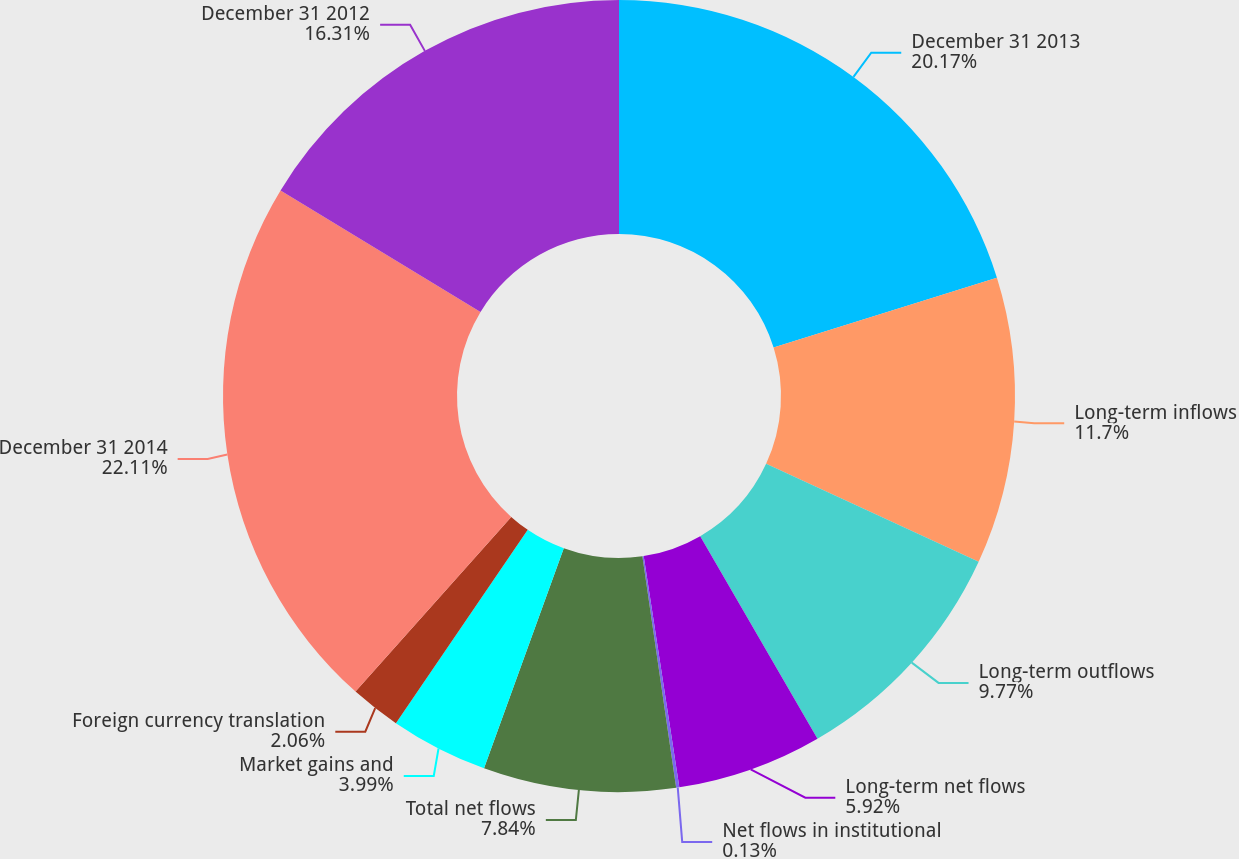<chart> <loc_0><loc_0><loc_500><loc_500><pie_chart><fcel>December 31 2013<fcel>Long-term inflows<fcel>Long-term outflows<fcel>Long-term net flows<fcel>Net flows in institutional<fcel>Total net flows<fcel>Market gains and<fcel>Foreign currency translation<fcel>December 31 2014<fcel>December 31 2012<nl><fcel>20.17%<fcel>11.7%<fcel>9.77%<fcel>5.92%<fcel>0.13%<fcel>7.84%<fcel>3.99%<fcel>2.06%<fcel>22.1%<fcel>16.31%<nl></chart> 